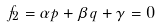Convert formula to latex. <formula><loc_0><loc_0><loc_500><loc_500>f _ { 2 } = \alpha p + \beta q + \gamma = 0</formula> 